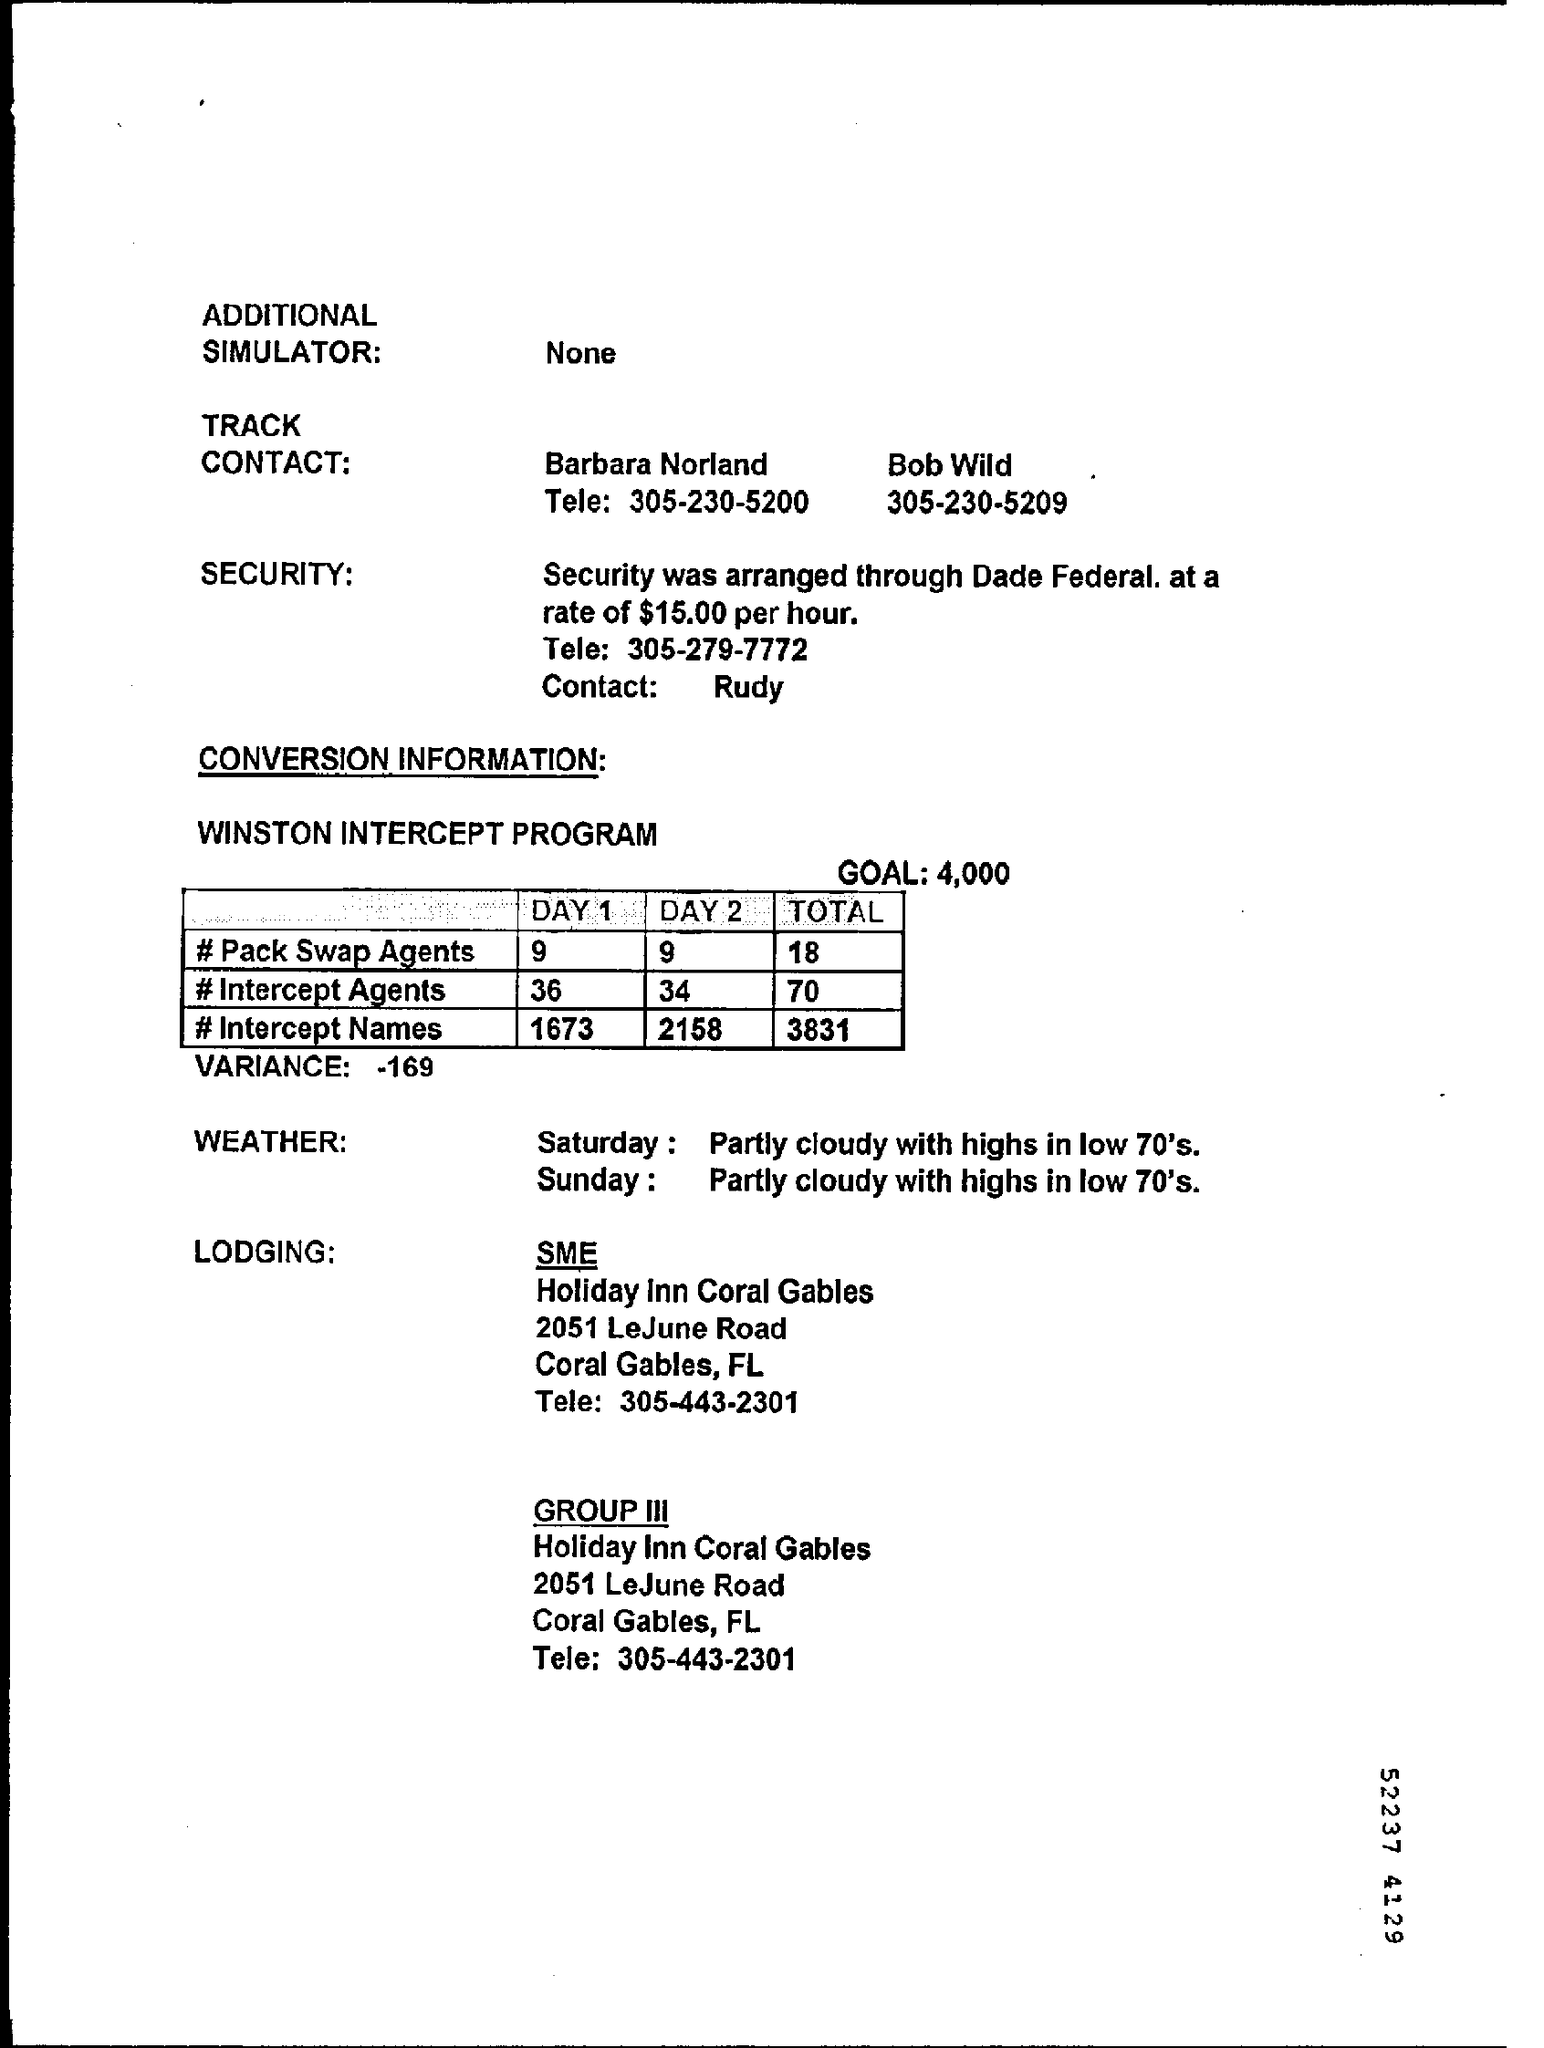How much a Security make up per hour?
Your answer should be very brief. $15.00. Who do you contact for SECURITY?
Keep it short and to the point. Rudy. What is GOAL of WINSTON INTERCEPT PROGRAM?
Your answer should be compact. 4,000. How many #Intercept Agents in DAY2?
Provide a short and direct response. 34. What is the TOTAL #Intercept Names ?
Ensure brevity in your answer.  3831. What kind of WEATHER was noticed on Sunday?
Provide a succinct answer. Partly cloudy with highs in low 70's. 